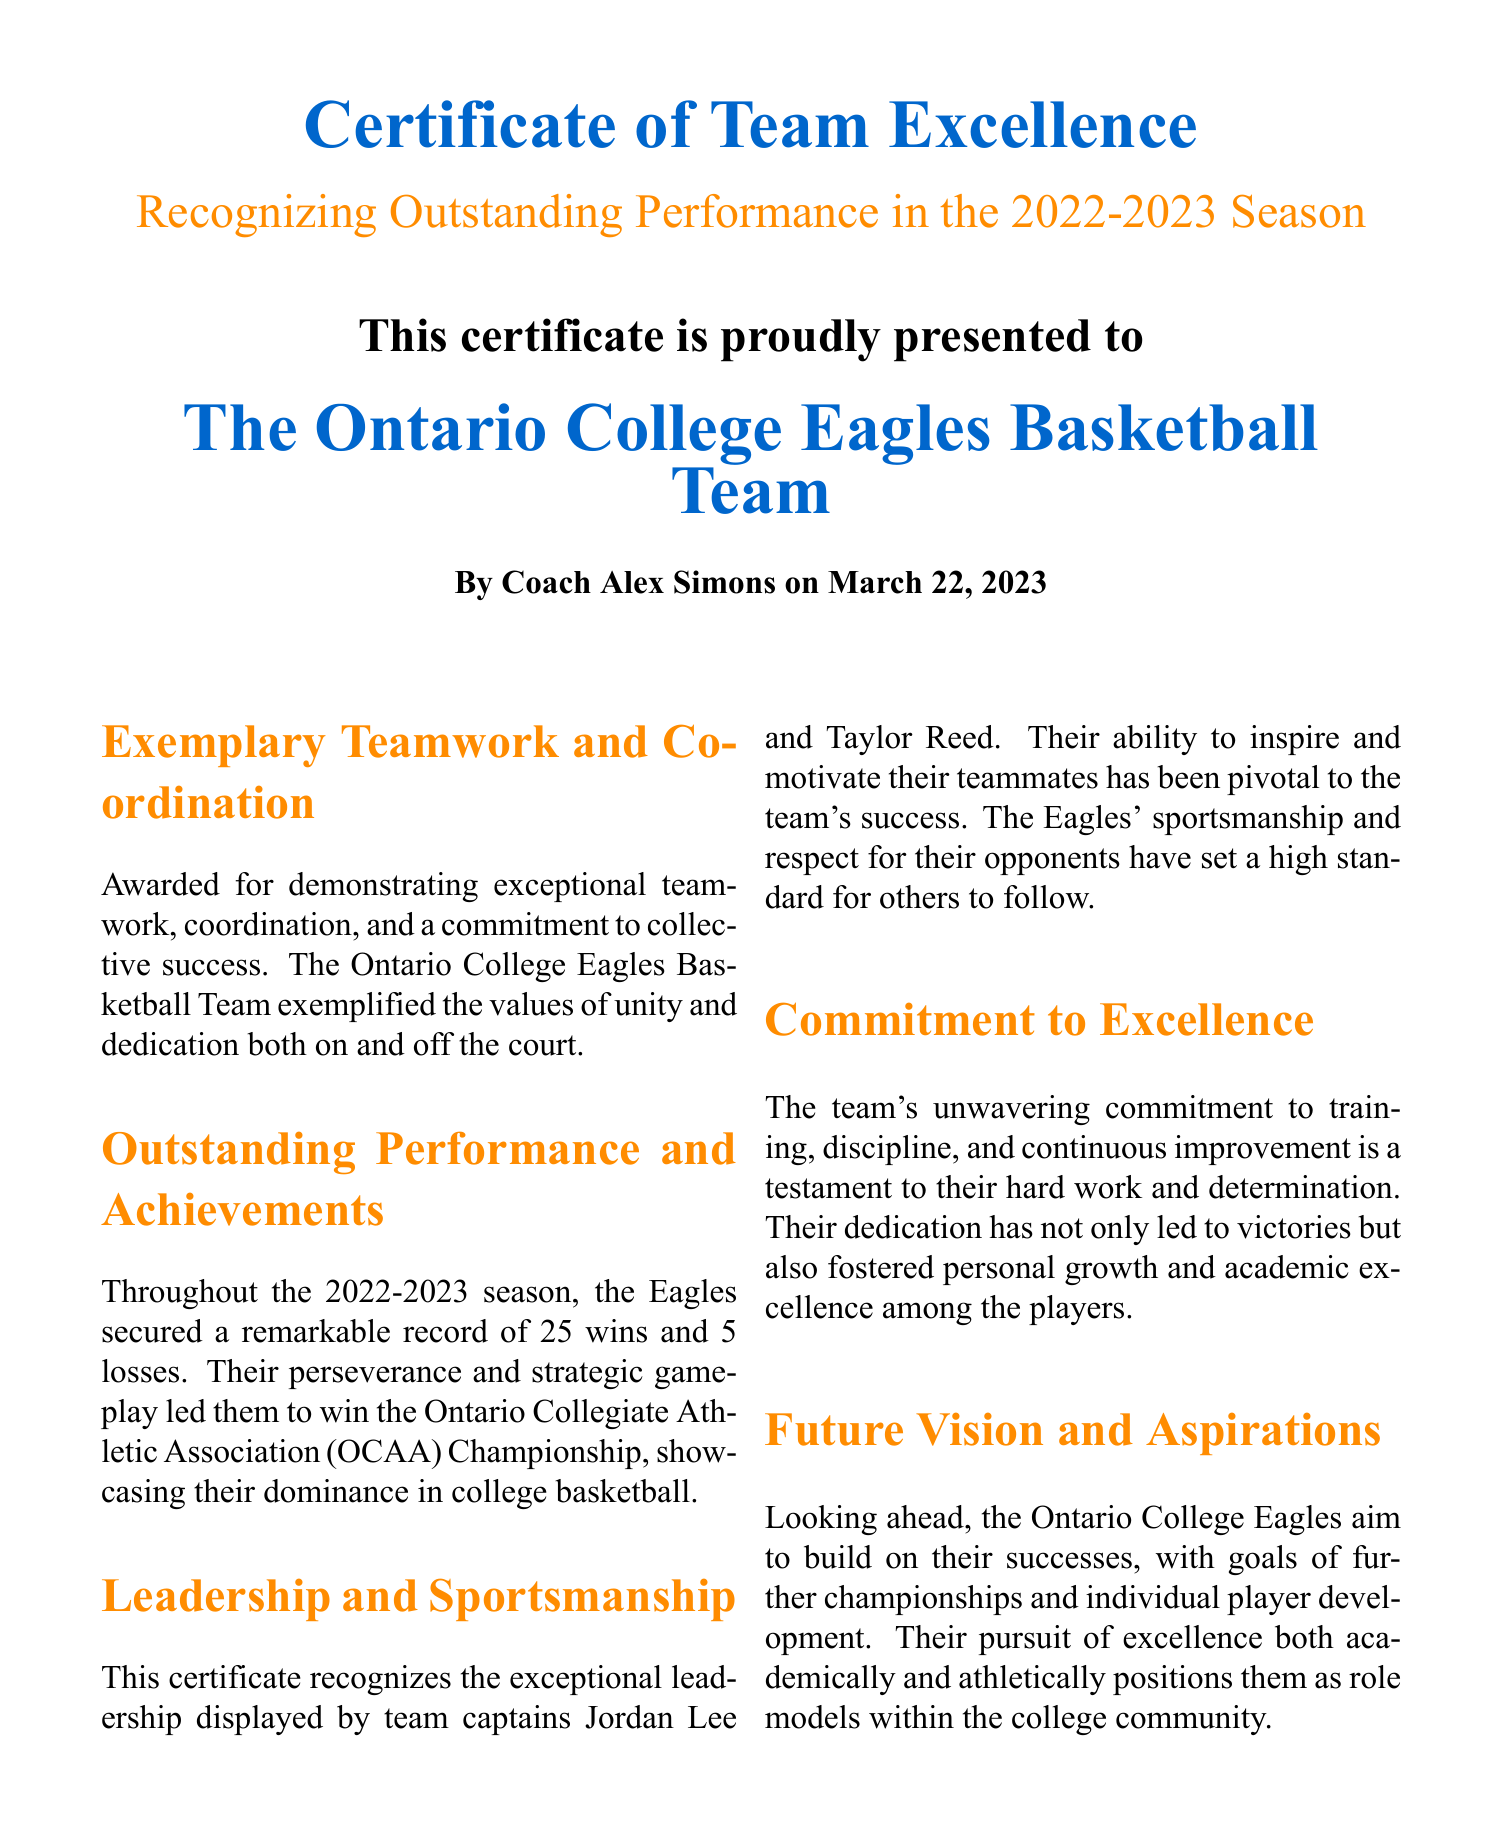What is the title of the certificate? The title of the certificate is prominently displayed at the top of the document.
Answer: Certificate of Team Excellence Who is the certificate presented to? The certificate specifically mentions the team that it recognizes.
Answer: The Ontario College Eagles Basketball Team What was the team's record during the 2022-2023 season? The document states the team's performance throughout the season.
Answer: 25 wins and 5 losses Who were the team captains recognized in the certificate? The certificate lists the names of the team captains who demonstrated leadership.
Answer: Jordan Lee and Taylor Reed What date was the certificate issued? The date on which the certificate was presented is included in the document.
Answer: March 22, 2023 What championship did the team win? The certificate highlights the significant achievement of the team during the season.
Answer: Ontario Collegiate Athletic Association (OCAA) Championship What is emphasized as part of the team's future vision? The document outlines the team's aspirations moving forward after the successful season.
Answer: Further championships and individual player development What color is the certificate title? The color used for the title adds to the document's design and emphasis.
Answer: Basketball orange 